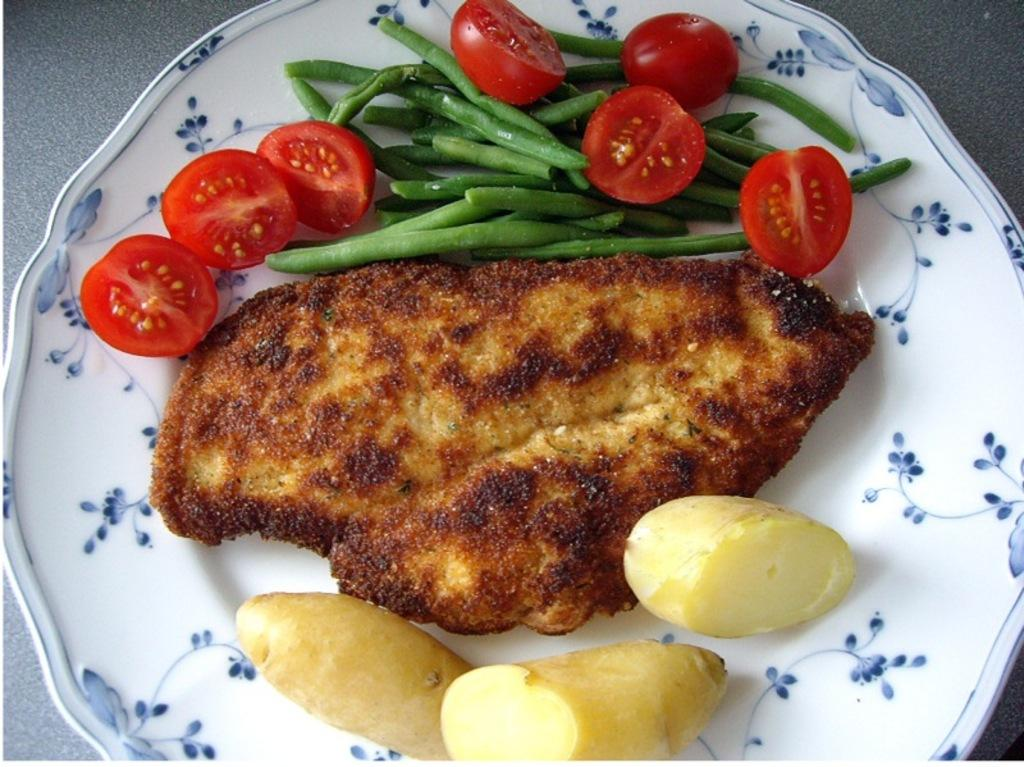What is on the plate that is visible in the image? There is food on a plate in the image. Where is the plate located in the image? The plate is on a table at the bottom of the image. What type of industry can be seen in the background of the image? There is no industry visible in the image; it only shows a plate of food on a table. 